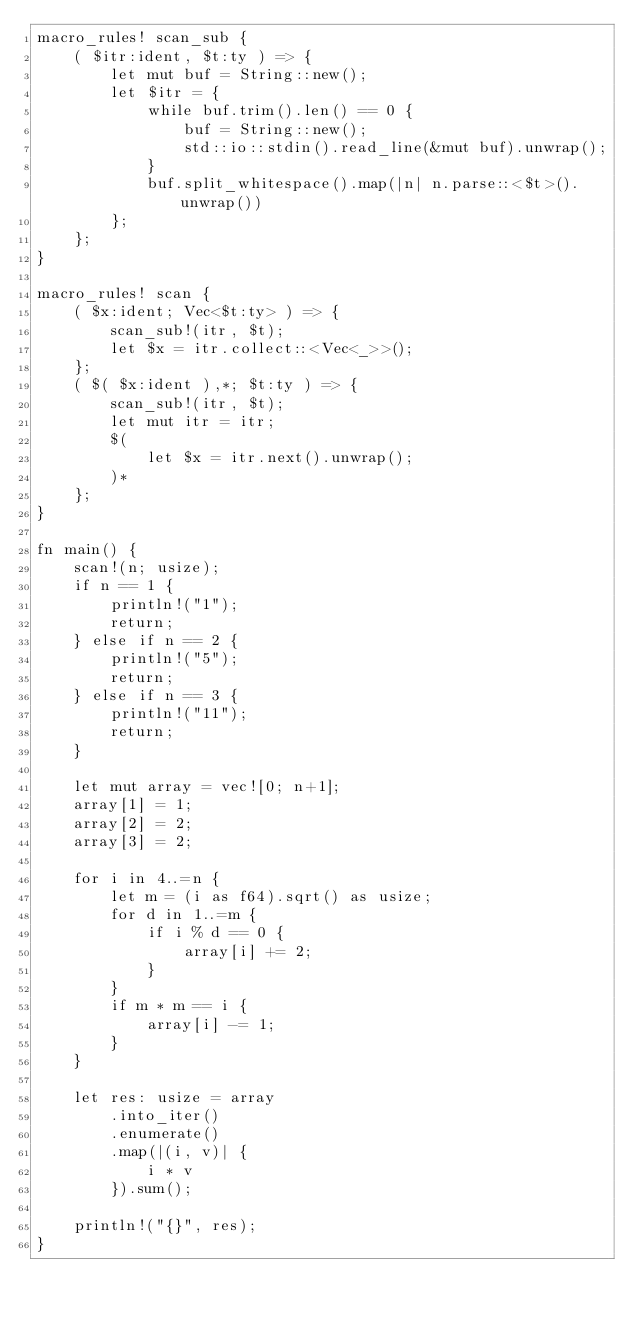Convert code to text. <code><loc_0><loc_0><loc_500><loc_500><_Rust_>macro_rules! scan_sub {
    ( $itr:ident, $t:ty ) => {
        let mut buf = String::new();
        let $itr = {
            while buf.trim().len() == 0 {
                buf = String::new();
                std::io::stdin().read_line(&mut buf).unwrap();
            }
            buf.split_whitespace().map(|n| n.parse::<$t>().unwrap())
        };
    };
}

macro_rules! scan {
    ( $x:ident; Vec<$t:ty> ) => {
        scan_sub!(itr, $t);
        let $x = itr.collect::<Vec<_>>();
    };
    ( $( $x:ident ),*; $t:ty ) => {
        scan_sub!(itr, $t);
        let mut itr = itr;
        $(
            let $x = itr.next().unwrap();
        )*
    };
}

fn main() {
    scan!(n; usize);
    if n == 1 {
        println!("1");
        return;
    } else if n == 2 {
        println!("5");
        return;
    } else if n == 3 {
        println!("11");
        return;
    }

    let mut array = vec![0; n+1];
    array[1] = 1;
    array[2] = 2;
    array[3] = 2;

    for i in 4..=n {
        let m = (i as f64).sqrt() as usize;
        for d in 1..=m {
            if i % d == 0 {
                array[i] += 2;
            }
        }
        if m * m == i {
            array[i] -= 1;
        }
    }

    let res: usize = array
        .into_iter()
        .enumerate()
        .map(|(i, v)| {
            i * v
        }).sum();

    println!("{}", res);
}
</code> 